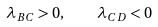Convert formula to latex. <formula><loc_0><loc_0><loc_500><loc_500>\lambda _ { B C } > 0 , \quad \lambda _ { C D } < 0</formula> 